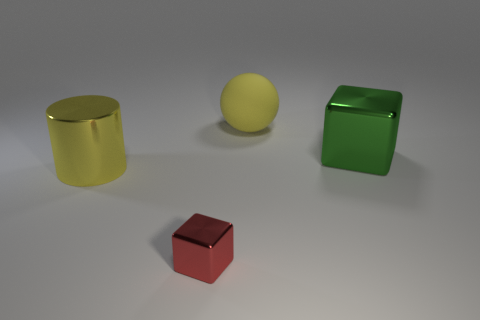Is there anything else that is the same size as the red shiny thing?
Your answer should be compact. No. Is there anything else that is the same shape as the yellow shiny object?
Ensure brevity in your answer.  No. There is a shiny block left of the yellow thing that is right of the big yellow object in front of the large yellow rubber thing; how big is it?
Your response must be concise. Small. There is a cylinder that is the same size as the green metal thing; what is its material?
Keep it short and to the point. Metal. Are there any matte spheres that have the same size as the green metal block?
Keep it short and to the point. Yes. Do the red thing and the big yellow matte thing have the same shape?
Your answer should be very brief. No. There is a big object that is in front of the shiny cube right of the big ball; are there any cubes that are right of it?
Make the answer very short. Yes. How many other things are there of the same color as the cylinder?
Your response must be concise. 1. Does the yellow object that is behind the cylinder have the same size as the block behind the tiny object?
Offer a terse response. Yes. Are there an equal number of cylinders that are right of the large yellow ball and small cubes that are on the right side of the big shiny cylinder?
Make the answer very short. No. 